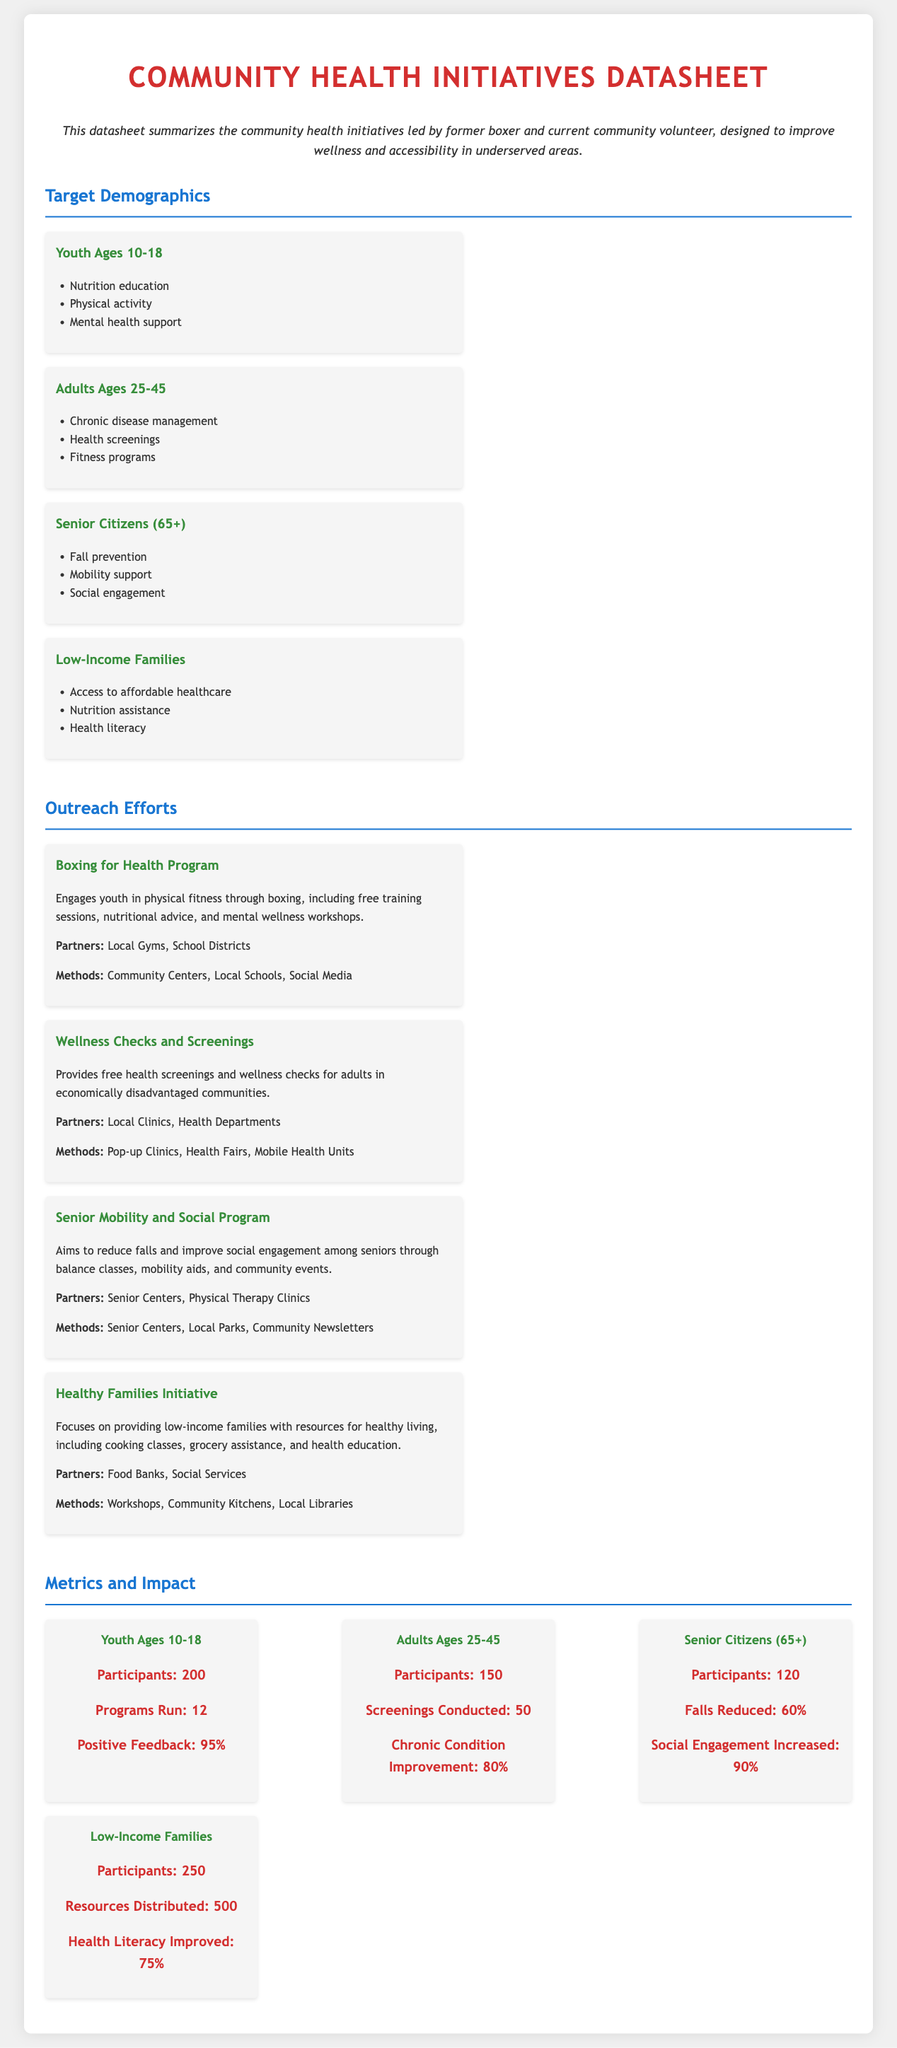what age group is targeted for nutrition education? The document states that nutrition education is provided to youth ages 10-18.
Answer: Youth Ages 10-18 how many programs were run for youth ages 10-18? The document indicates that 12 programs were run for youth ages 10-18.
Answer: 12 what percentage of positive feedback was received from youth participants? According to the metrics, 95% of participants provided positive feedback.
Answer: 95% which initiative focuses on providing resources for healthy living to low-income families? The document specifies the Healthy Families Initiative as the program for low-income families.
Answer: Healthy Families Initiative how many participants were there in the Senior Mobility and Social Program? The metrics section lists 120 participants in the Senior Citizens (65+) category.
Answer: 120 which partners are associated with the Boxing for Health Program? The partners listed for the Boxing for Health Program are Local Gyms and School Districts.
Answer: Local Gyms, School Districts how much was the fall reduction percentage among seniors? The document states that falls were reduced by 60% among senior citizens.
Answer: 60% what type of methods does the Healthy Families Initiative use? The methods include workshops, community kitchens, and local libraries as specified in the outreach section.
Answer: Workshops, Community Kitchens, Local Libraries what was the improvement percentage for health literacy among low-income families? The document notes that health literacy improved by 75% for low-income families.
Answer: 75% 